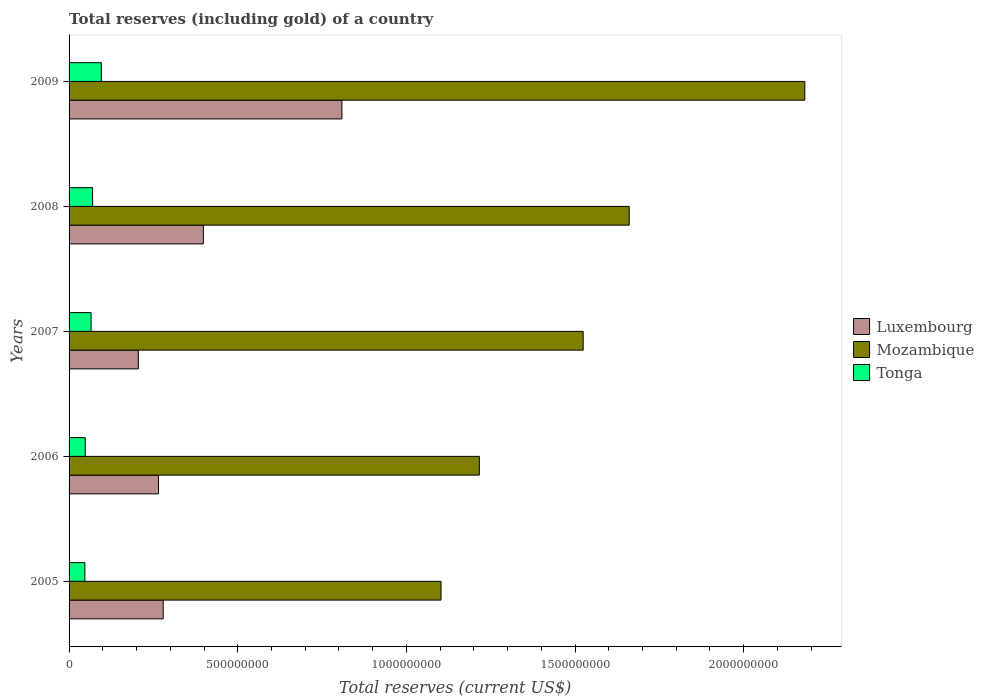How many groups of bars are there?
Offer a terse response. 5. Are the number of bars on each tick of the Y-axis equal?
Make the answer very short. Yes. How many bars are there on the 2nd tick from the bottom?
Offer a terse response. 3. What is the total reserves (including gold) in Tonga in 2008?
Your response must be concise. 6.98e+07. Across all years, what is the maximum total reserves (including gold) in Mozambique?
Your response must be concise. 2.18e+09. Across all years, what is the minimum total reserves (including gold) in Tonga?
Provide a short and direct response. 4.69e+07. What is the total total reserves (including gold) in Luxembourg in the graph?
Keep it short and to the point. 1.96e+09. What is the difference between the total reserves (including gold) in Mozambique in 2006 and that in 2008?
Provide a short and direct response. -4.44e+08. What is the difference between the total reserves (including gold) in Mozambique in 2009 and the total reserves (including gold) in Luxembourg in 2008?
Your response must be concise. 1.78e+09. What is the average total reserves (including gold) in Luxembourg per year?
Keep it short and to the point. 3.91e+08. In the year 2006, what is the difference between the total reserves (including gold) in Mozambique and total reserves (including gold) in Luxembourg?
Offer a very short reply. 9.51e+08. What is the ratio of the total reserves (including gold) in Luxembourg in 2007 to that in 2009?
Ensure brevity in your answer.  0.25. Is the total reserves (including gold) in Tonga in 2006 less than that in 2009?
Keep it short and to the point. Yes. Is the difference between the total reserves (including gold) in Mozambique in 2006 and 2008 greater than the difference between the total reserves (including gold) in Luxembourg in 2006 and 2008?
Offer a very short reply. No. What is the difference between the highest and the second highest total reserves (including gold) in Luxembourg?
Your answer should be very brief. 4.11e+08. What is the difference between the highest and the lowest total reserves (including gold) in Mozambique?
Provide a succinct answer. 1.08e+09. Is the sum of the total reserves (including gold) in Tonga in 2005 and 2009 greater than the maximum total reserves (including gold) in Luxembourg across all years?
Ensure brevity in your answer.  No. What does the 1st bar from the top in 2005 represents?
Provide a short and direct response. Tonga. What does the 3rd bar from the bottom in 2008 represents?
Your answer should be compact. Tonga. How many bars are there?
Your response must be concise. 15. Are the values on the major ticks of X-axis written in scientific E-notation?
Ensure brevity in your answer.  No. Does the graph contain any zero values?
Offer a terse response. No. Where does the legend appear in the graph?
Keep it short and to the point. Center right. How many legend labels are there?
Your response must be concise. 3. How are the legend labels stacked?
Ensure brevity in your answer.  Vertical. What is the title of the graph?
Give a very brief answer. Total reserves (including gold) of a country. What is the label or title of the X-axis?
Offer a terse response. Total reserves (current US$). What is the label or title of the Y-axis?
Make the answer very short. Years. What is the Total reserves (current US$) in Luxembourg in 2005?
Your answer should be compact. 2.79e+08. What is the Total reserves (current US$) in Mozambique in 2005?
Your answer should be very brief. 1.10e+09. What is the Total reserves (current US$) of Tonga in 2005?
Provide a short and direct response. 4.69e+07. What is the Total reserves (current US$) in Luxembourg in 2006?
Make the answer very short. 2.65e+08. What is the Total reserves (current US$) in Mozambique in 2006?
Provide a succinct answer. 1.22e+09. What is the Total reserves (current US$) in Tonga in 2006?
Provide a short and direct response. 4.80e+07. What is the Total reserves (current US$) of Luxembourg in 2007?
Your answer should be compact. 2.05e+08. What is the Total reserves (current US$) of Mozambique in 2007?
Keep it short and to the point. 1.52e+09. What is the Total reserves (current US$) of Tonga in 2007?
Your answer should be compact. 6.52e+07. What is the Total reserves (current US$) of Luxembourg in 2008?
Your answer should be very brief. 3.98e+08. What is the Total reserves (current US$) in Mozambique in 2008?
Make the answer very short. 1.66e+09. What is the Total reserves (current US$) of Tonga in 2008?
Your answer should be very brief. 6.98e+07. What is the Total reserves (current US$) of Luxembourg in 2009?
Offer a very short reply. 8.09e+08. What is the Total reserves (current US$) in Mozambique in 2009?
Your answer should be very brief. 2.18e+09. What is the Total reserves (current US$) in Tonga in 2009?
Your answer should be very brief. 9.57e+07. Across all years, what is the maximum Total reserves (current US$) in Luxembourg?
Offer a very short reply. 8.09e+08. Across all years, what is the maximum Total reserves (current US$) of Mozambique?
Ensure brevity in your answer.  2.18e+09. Across all years, what is the maximum Total reserves (current US$) in Tonga?
Your response must be concise. 9.57e+07. Across all years, what is the minimum Total reserves (current US$) in Luxembourg?
Your answer should be very brief. 2.05e+08. Across all years, what is the minimum Total reserves (current US$) in Mozambique?
Your answer should be very brief. 1.10e+09. Across all years, what is the minimum Total reserves (current US$) in Tonga?
Keep it short and to the point. 4.69e+07. What is the total Total reserves (current US$) in Luxembourg in the graph?
Your answer should be very brief. 1.96e+09. What is the total Total reserves (current US$) of Mozambique in the graph?
Provide a succinct answer. 7.68e+09. What is the total Total reserves (current US$) of Tonga in the graph?
Make the answer very short. 3.26e+08. What is the difference between the Total reserves (current US$) in Luxembourg in 2005 and that in 2006?
Ensure brevity in your answer.  1.39e+07. What is the difference between the Total reserves (current US$) of Mozambique in 2005 and that in 2006?
Offer a very short reply. -1.14e+08. What is the difference between the Total reserves (current US$) in Tonga in 2005 and that in 2006?
Offer a terse response. -1.11e+06. What is the difference between the Total reserves (current US$) in Luxembourg in 2005 and that in 2007?
Your answer should be compact. 7.38e+07. What is the difference between the Total reserves (current US$) of Mozambique in 2005 and that in 2007?
Your answer should be very brief. -4.21e+08. What is the difference between the Total reserves (current US$) of Tonga in 2005 and that in 2007?
Ensure brevity in your answer.  -1.84e+07. What is the difference between the Total reserves (current US$) of Luxembourg in 2005 and that in 2008?
Provide a short and direct response. -1.19e+08. What is the difference between the Total reserves (current US$) in Mozambique in 2005 and that in 2008?
Make the answer very short. -5.58e+08. What is the difference between the Total reserves (current US$) in Tonga in 2005 and that in 2008?
Ensure brevity in your answer.  -2.29e+07. What is the difference between the Total reserves (current US$) in Luxembourg in 2005 and that in 2009?
Offer a terse response. -5.30e+08. What is the difference between the Total reserves (current US$) of Mozambique in 2005 and that in 2009?
Provide a succinct answer. -1.08e+09. What is the difference between the Total reserves (current US$) of Tonga in 2005 and that in 2009?
Offer a terse response. -4.88e+07. What is the difference between the Total reserves (current US$) of Luxembourg in 2006 and that in 2007?
Keep it short and to the point. 5.99e+07. What is the difference between the Total reserves (current US$) in Mozambique in 2006 and that in 2007?
Provide a short and direct response. -3.08e+08. What is the difference between the Total reserves (current US$) of Tonga in 2006 and that in 2007?
Provide a short and direct response. -1.73e+07. What is the difference between the Total reserves (current US$) in Luxembourg in 2006 and that in 2008?
Provide a short and direct response. -1.33e+08. What is the difference between the Total reserves (current US$) in Mozambique in 2006 and that in 2008?
Your answer should be compact. -4.44e+08. What is the difference between the Total reserves (current US$) in Tonga in 2006 and that in 2008?
Your answer should be compact. -2.18e+07. What is the difference between the Total reserves (current US$) in Luxembourg in 2006 and that in 2009?
Offer a terse response. -5.44e+08. What is the difference between the Total reserves (current US$) of Mozambique in 2006 and that in 2009?
Provide a succinct answer. -9.65e+08. What is the difference between the Total reserves (current US$) in Tonga in 2006 and that in 2009?
Provide a short and direct response. -4.77e+07. What is the difference between the Total reserves (current US$) in Luxembourg in 2007 and that in 2008?
Offer a very short reply. -1.93e+08. What is the difference between the Total reserves (current US$) in Mozambique in 2007 and that in 2008?
Provide a succinct answer. -1.36e+08. What is the difference between the Total reserves (current US$) in Tonga in 2007 and that in 2008?
Offer a terse response. -4.52e+06. What is the difference between the Total reserves (current US$) of Luxembourg in 2007 and that in 2009?
Offer a very short reply. -6.04e+08. What is the difference between the Total reserves (current US$) of Mozambique in 2007 and that in 2009?
Keep it short and to the point. -6.57e+08. What is the difference between the Total reserves (current US$) in Tonga in 2007 and that in 2009?
Provide a succinct answer. -3.05e+07. What is the difference between the Total reserves (current US$) of Luxembourg in 2008 and that in 2009?
Your response must be concise. -4.11e+08. What is the difference between the Total reserves (current US$) in Mozambique in 2008 and that in 2009?
Ensure brevity in your answer.  -5.21e+08. What is the difference between the Total reserves (current US$) in Tonga in 2008 and that in 2009?
Ensure brevity in your answer.  -2.59e+07. What is the difference between the Total reserves (current US$) in Luxembourg in 2005 and the Total reserves (current US$) in Mozambique in 2006?
Keep it short and to the point. -9.37e+08. What is the difference between the Total reserves (current US$) in Luxembourg in 2005 and the Total reserves (current US$) in Tonga in 2006?
Ensure brevity in your answer.  2.31e+08. What is the difference between the Total reserves (current US$) of Mozambique in 2005 and the Total reserves (current US$) of Tonga in 2006?
Provide a succinct answer. 1.05e+09. What is the difference between the Total reserves (current US$) in Luxembourg in 2005 and the Total reserves (current US$) in Mozambique in 2007?
Offer a terse response. -1.25e+09. What is the difference between the Total reserves (current US$) of Luxembourg in 2005 and the Total reserves (current US$) of Tonga in 2007?
Make the answer very short. 2.14e+08. What is the difference between the Total reserves (current US$) of Mozambique in 2005 and the Total reserves (current US$) of Tonga in 2007?
Your response must be concise. 1.04e+09. What is the difference between the Total reserves (current US$) of Luxembourg in 2005 and the Total reserves (current US$) of Mozambique in 2008?
Offer a terse response. -1.38e+09. What is the difference between the Total reserves (current US$) of Luxembourg in 2005 and the Total reserves (current US$) of Tonga in 2008?
Provide a succinct answer. 2.09e+08. What is the difference between the Total reserves (current US$) in Mozambique in 2005 and the Total reserves (current US$) in Tonga in 2008?
Make the answer very short. 1.03e+09. What is the difference between the Total reserves (current US$) in Luxembourg in 2005 and the Total reserves (current US$) in Mozambique in 2009?
Provide a succinct answer. -1.90e+09. What is the difference between the Total reserves (current US$) in Luxembourg in 2005 and the Total reserves (current US$) in Tonga in 2009?
Your answer should be compact. 1.83e+08. What is the difference between the Total reserves (current US$) of Mozambique in 2005 and the Total reserves (current US$) of Tonga in 2009?
Offer a terse response. 1.01e+09. What is the difference between the Total reserves (current US$) in Luxembourg in 2006 and the Total reserves (current US$) in Mozambique in 2007?
Keep it short and to the point. -1.26e+09. What is the difference between the Total reserves (current US$) in Luxembourg in 2006 and the Total reserves (current US$) in Tonga in 2007?
Your response must be concise. 2.00e+08. What is the difference between the Total reserves (current US$) of Mozambique in 2006 and the Total reserves (current US$) of Tonga in 2007?
Your response must be concise. 1.15e+09. What is the difference between the Total reserves (current US$) of Luxembourg in 2006 and the Total reserves (current US$) of Mozambique in 2008?
Give a very brief answer. -1.40e+09. What is the difference between the Total reserves (current US$) of Luxembourg in 2006 and the Total reserves (current US$) of Tonga in 2008?
Make the answer very short. 1.95e+08. What is the difference between the Total reserves (current US$) of Mozambique in 2006 and the Total reserves (current US$) of Tonga in 2008?
Provide a succinct answer. 1.15e+09. What is the difference between the Total reserves (current US$) of Luxembourg in 2006 and the Total reserves (current US$) of Mozambique in 2009?
Give a very brief answer. -1.92e+09. What is the difference between the Total reserves (current US$) in Luxembourg in 2006 and the Total reserves (current US$) in Tonga in 2009?
Offer a very short reply. 1.69e+08. What is the difference between the Total reserves (current US$) of Mozambique in 2006 and the Total reserves (current US$) of Tonga in 2009?
Keep it short and to the point. 1.12e+09. What is the difference between the Total reserves (current US$) in Luxembourg in 2007 and the Total reserves (current US$) in Mozambique in 2008?
Provide a succinct answer. -1.46e+09. What is the difference between the Total reserves (current US$) of Luxembourg in 2007 and the Total reserves (current US$) of Tonga in 2008?
Your answer should be very brief. 1.35e+08. What is the difference between the Total reserves (current US$) in Mozambique in 2007 and the Total reserves (current US$) in Tonga in 2008?
Provide a succinct answer. 1.45e+09. What is the difference between the Total reserves (current US$) of Luxembourg in 2007 and the Total reserves (current US$) of Mozambique in 2009?
Your answer should be compact. -1.98e+09. What is the difference between the Total reserves (current US$) in Luxembourg in 2007 and the Total reserves (current US$) in Tonga in 2009?
Offer a very short reply. 1.10e+08. What is the difference between the Total reserves (current US$) in Mozambique in 2007 and the Total reserves (current US$) in Tonga in 2009?
Keep it short and to the point. 1.43e+09. What is the difference between the Total reserves (current US$) in Luxembourg in 2008 and the Total reserves (current US$) in Mozambique in 2009?
Your response must be concise. -1.78e+09. What is the difference between the Total reserves (current US$) of Luxembourg in 2008 and the Total reserves (current US$) of Tonga in 2009?
Offer a terse response. 3.02e+08. What is the difference between the Total reserves (current US$) in Mozambique in 2008 and the Total reserves (current US$) in Tonga in 2009?
Your answer should be compact. 1.56e+09. What is the average Total reserves (current US$) in Luxembourg per year?
Offer a very short reply. 3.91e+08. What is the average Total reserves (current US$) in Mozambique per year?
Your response must be concise. 1.54e+09. What is the average Total reserves (current US$) in Tonga per year?
Offer a terse response. 6.51e+07. In the year 2005, what is the difference between the Total reserves (current US$) in Luxembourg and Total reserves (current US$) in Mozambique?
Offer a terse response. -8.24e+08. In the year 2005, what is the difference between the Total reserves (current US$) in Luxembourg and Total reserves (current US$) in Tonga?
Make the answer very short. 2.32e+08. In the year 2005, what is the difference between the Total reserves (current US$) of Mozambique and Total reserves (current US$) of Tonga?
Offer a very short reply. 1.06e+09. In the year 2006, what is the difference between the Total reserves (current US$) of Luxembourg and Total reserves (current US$) of Mozambique?
Your answer should be very brief. -9.51e+08. In the year 2006, what is the difference between the Total reserves (current US$) in Luxembourg and Total reserves (current US$) in Tonga?
Offer a terse response. 2.17e+08. In the year 2006, what is the difference between the Total reserves (current US$) in Mozambique and Total reserves (current US$) in Tonga?
Give a very brief answer. 1.17e+09. In the year 2007, what is the difference between the Total reserves (current US$) in Luxembourg and Total reserves (current US$) in Mozambique?
Offer a terse response. -1.32e+09. In the year 2007, what is the difference between the Total reserves (current US$) of Luxembourg and Total reserves (current US$) of Tonga?
Offer a terse response. 1.40e+08. In the year 2007, what is the difference between the Total reserves (current US$) in Mozambique and Total reserves (current US$) in Tonga?
Your response must be concise. 1.46e+09. In the year 2008, what is the difference between the Total reserves (current US$) in Luxembourg and Total reserves (current US$) in Mozambique?
Provide a succinct answer. -1.26e+09. In the year 2008, what is the difference between the Total reserves (current US$) of Luxembourg and Total reserves (current US$) of Tonga?
Offer a terse response. 3.28e+08. In the year 2008, what is the difference between the Total reserves (current US$) in Mozambique and Total reserves (current US$) in Tonga?
Make the answer very short. 1.59e+09. In the year 2009, what is the difference between the Total reserves (current US$) in Luxembourg and Total reserves (current US$) in Mozambique?
Offer a terse response. -1.37e+09. In the year 2009, what is the difference between the Total reserves (current US$) in Luxembourg and Total reserves (current US$) in Tonga?
Make the answer very short. 7.13e+08. In the year 2009, what is the difference between the Total reserves (current US$) of Mozambique and Total reserves (current US$) of Tonga?
Offer a terse response. 2.09e+09. What is the ratio of the Total reserves (current US$) of Luxembourg in 2005 to that in 2006?
Your answer should be compact. 1.05. What is the ratio of the Total reserves (current US$) of Mozambique in 2005 to that in 2006?
Your response must be concise. 0.91. What is the ratio of the Total reserves (current US$) of Tonga in 2005 to that in 2006?
Ensure brevity in your answer.  0.98. What is the ratio of the Total reserves (current US$) in Luxembourg in 2005 to that in 2007?
Your answer should be compact. 1.36. What is the ratio of the Total reserves (current US$) of Mozambique in 2005 to that in 2007?
Your answer should be compact. 0.72. What is the ratio of the Total reserves (current US$) of Tonga in 2005 to that in 2007?
Your response must be concise. 0.72. What is the ratio of the Total reserves (current US$) in Luxembourg in 2005 to that in 2008?
Provide a short and direct response. 0.7. What is the ratio of the Total reserves (current US$) of Mozambique in 2005 to that in 2008?
Make the answer very short. 0.66. What is the ratio of the Total reserves (current US$) in Tonga in 2005 to that in 2008?
Ensure brevity in your answer.  0.67. What is the ratio of the Total reserves (current US$) of Luxembourg in 2005 to that in 2009?
Ensure brevity in your answer.  0.34. What is the ratio of the Total reserves (current US$) in Mozambique in 2005 to that in 2009?
Your answer should be very brief. 0.51. What is the ratio of the Total reserves (current US$) of Tonga in 2005 to that in 2009?
Give a very brief answer. 0.49. What is the ratio of the Total reserves (current US$) in Luxembourg in 2006 to that in 2007?
Ensure brevity in your answer.  1.29. What is the ratio of the Total reserves (current US$) of Mozambique in 2006 to that in 2007?
Your answer should be compact. 0.8. What is the ratio of the Total reserves (current US$) in Tonga in 2006 to that in 2007?
Keep it short and to the point. 0.74. What is the ratio of the Total reserves (current US$) in Luxembourg in 2006 to that in 2008?
Keep it short and to the point. 0.67. What is the ratio of the Total reserves (current US$) of Mozambique in 2006 to that in 2008?
Ensure brevity in your answer.  0.73. What is the ratio of the Total reserves (current US$) in Tonga in 2006 to that in 2008?
Give a very brief answer. 0.69. What is the ratio of the Total reserves (current US$) in Luxembourg in 2006 to that in 2009?
Keep it short and to the point. 0.33. What is the ratio of the Total reserves (current US$) of Mozambique in 2006 to that in 2009?
Your response must be concise. 0.56. What is the ratio of the Total reserves (current US$) in Tonga in 2006 to that in 2009?
Keep it short and to the point. 0.5. What is the ratio of the Total reserves (current US$) of Luxembourg in 2007 to that in 2008?
Offer a very short reply. 0.52. What is the ratio of the Total reserves (current US$) of Mozambique in 2007 to that in 2008?
Offer a terse response. 0.92. What is the ratio of the Total reserves (current US$) in Tonga in 2007 to that in 2008?
Keep it short and to the point. 0.94. What is the ratio of the Total reserves (current US$) in Luxembourg in 2007 to that in 2009?
Provide a short and direct response. 0.25. What is the ratio of the Total reserves (current US$) of Mozambique in 2007 to that in 2009?
Offer a very short reply. 0.7. What is the ratio of the Total reserves (current US$) of Tonga in 2007 to that in 2009?
Give a very brief answer. 0.68. What is the ratio of the Total reserves (current US$) in Luxembourg in 2008 to that in 2009?
Provide a succinct answer. 0.49. What is the ratio of the Total reserves (current US$) of Mozambique in 2008 to that in 2009?
Offer a terse response. 0.76. What is the ratio of the Total reserves (current US$) of Tonga in 2008 to that in 2009?
Ensure brevity in your answer.  0.73. What is the difference between the highest and the second highest Total reserves (current US$) in Luxembourg?
Give a very brief answer. 4.11e+08. What is the difference between the highest and the second highest Total reserves (current US$) of Mozambique?
Your response must be concise. 5.21e+08. What is the difference between the highest and the second highest Total reserves (current US$) in Tonga?
Ensure brevity in your answer.  2.59e+07. What is the difference between the highest and the lowest Total reserves (current US$) in Luxembourg?
Offer a terse response. 6.04e+08. What is the difference between the highest and the lowest Total reserves (current US$) of Mozambique?
Make the answer very short. 1.08e+09. What is the difference between the highest and the lowest Total reserves (current US$) in Tonga?
Give a very brief answer. 4.88e+07. 